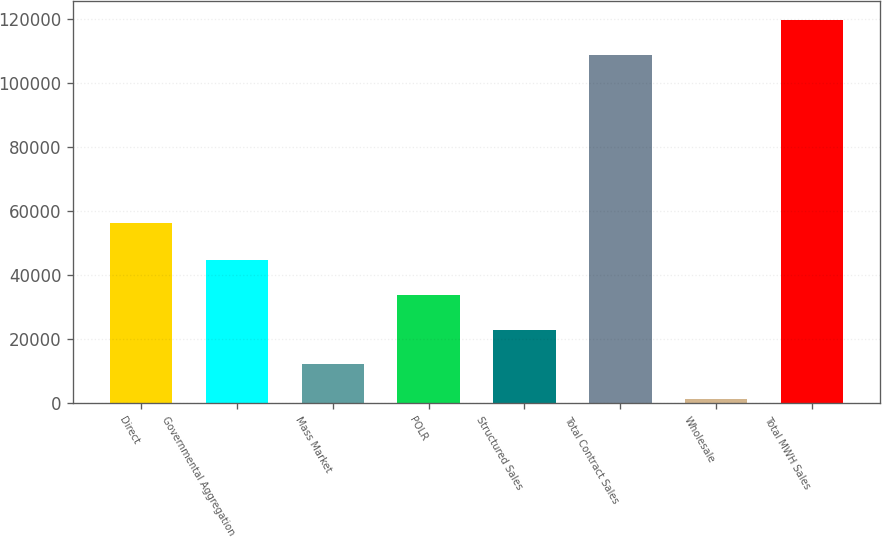Convert chart to OTSL. <chart><loc_0><loc_0><loc_500><loc_500><bar_chart><fcel>Direct<fcel>Governmental Aggregation<fcel>Mass Market<fcel>POLR<fcel>Structured Sales<fcel>Total Contract Sales<fcel>Wholesale<fcel>Total MWH Sales<nl><fcel>56145<fcel>44678<fcel>12107<fcel>33821<fcel>22964<fcel>108570<fcel>1250<fcel>119427<nl></chart> 